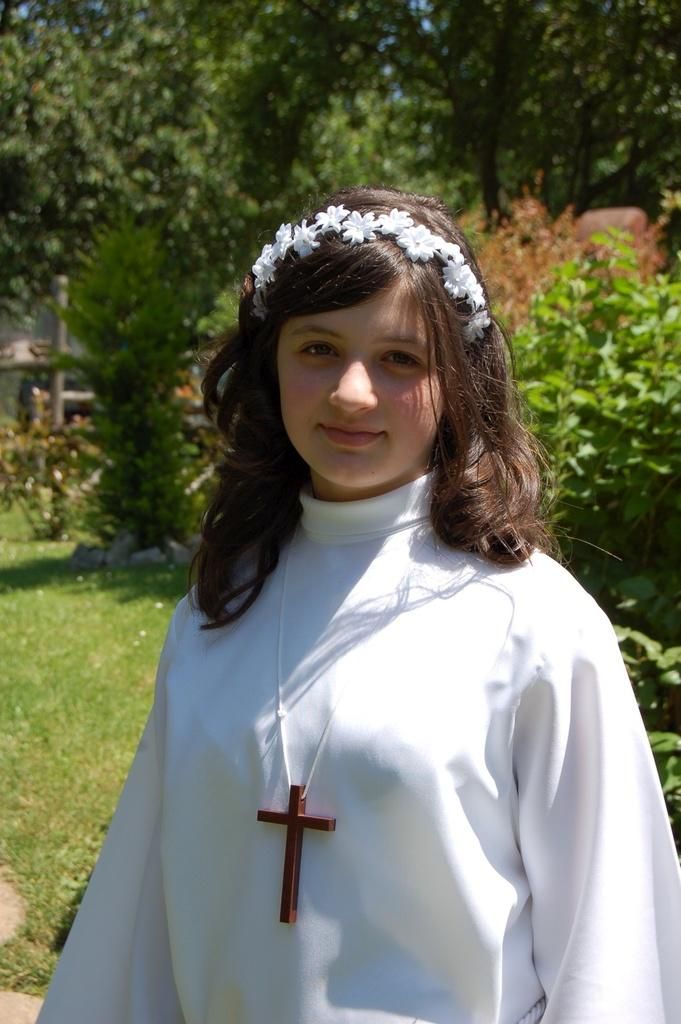What is the main subject of the image? There is a woman standing in the image. What type of natural environment is visible in the image? There is grass, plants, and a group of trees visible in the image. What is the pole used for in the image? The purpose of the pole is not specified in the image. What is visible in the sky in the image? The sky is visible in the image, but no specific details are provided. What type of badge is the woman wearing in the image? There is no badge visible on the woman in the image. What color are the trousers the woman is wearing in the image? The color of the woman's trousers is not specified in the image. 